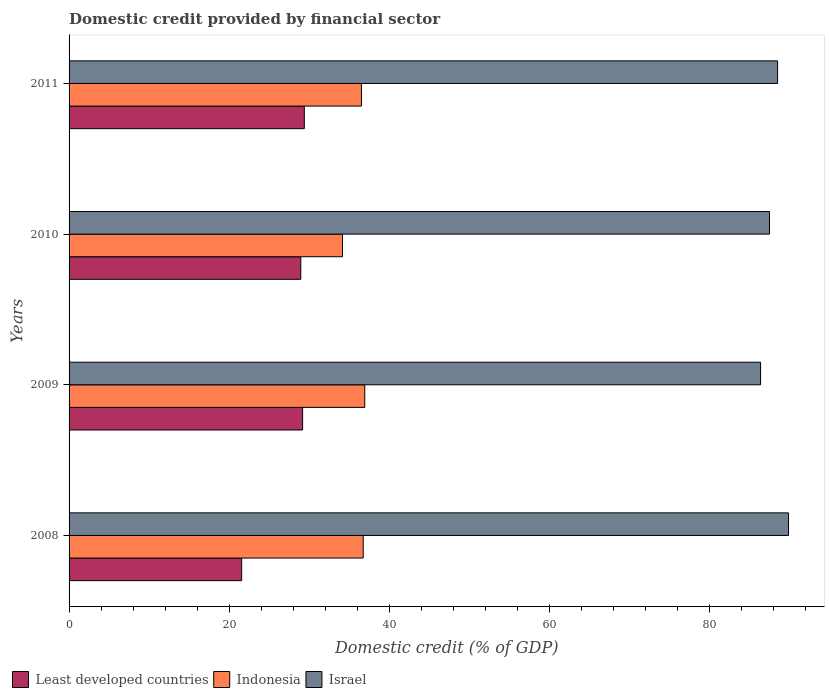How many groups of bars are there?
Give a very brief answer. 4. How many bars are there on the 4th tick from the top?
Your answer should be very brief. 3. How many bars are there on the 1st tick from the bottom?
Provide a succinct answer. 3. What is the label of the 1st group of bars from the top?
Give a very brief answer. 2011. What is the domestic credit in Least developed countries in 2009?
Offer a very short reply. 29.19. Across all years, what is the maximum domestic credit in Least developed countries?
Offer a terse response. 29.41. Across all years, what is the minimum domestic credit in Indonesia?
Provide a succinct answer. 34.18. What is the total domestic credit in Israel in the graph?
Your answer should be very brief. 352.52. What is the difference between the domestic credit in Israel in 2008 and that in 2009?
Make the answer very short. 3.49. What is the difference between the domestic credit in Least developed countries in 2010 and the domestic credit in Israel in 2008?
Your answer should be compact. -60.97. What is the average domestic credit in Indonesia per year?
Offer a very short reply. 36.12. In the year 2009, what is the difference between the domestic credit in Indonesia and domestic credit in Israel?
Your answer should be compact. -49.48. What is the ratio of the domestic credit in Israel in 2008 to that in 2011?
Your response must be concise. 1.02. Is the domestic credit in Indonesia in 2010 less than that in 2011?
Give a very brief answer. Yes. Is the difference between the domestic credit in Indonesia in 2008 and 2010 greater than the difference between the domestic credit in Israel in 2008 and 2010?
Offer a terse response. Yes. What is the difference between the highest and the second highest domestic credit in Indonesia?
Provide a short and direct response. 0.2. What is the difference between the highest and the lowest domestic credit in Indonesia?
Ensure brevity in your answer.  2.78. Is the sum of the domestic credit in Indonesia in 2009 and 2011 greater than the maximum domestic credit in Least developed countries across all years?
Your answer should be compact. Yes. What does the 3rd bar from the top in 2011 represents?
Make the answer very short. Least developed countries. What is the difference between two consecutive major ticks on the X-axis?
Your answer should be very brief. 20. Does the graph contain grids?
Offer a terse response. No. Where does the legend appear in the graph?
Your answer should be very brief. Bottom left. How are the legend labels stacked?
Your answer should be compact. Horizontal. What is the title of the graph?
Make the answer very short. Domestic credit provided by financial sector. Does "Zambia" appear as one of the legend labels in the graph?
Your answer should be compact. No. What is the label or title of the X-axis?
Your answer should be compact. Domestic credit (% of GDP). What is the Domestic credit (% of GDP) in Least developed countries in 2008?
Ensure brevity in your answer.  21.58. What is the Domestic credit (% of GDP) of Indonesia in 2008?
Ensure brevity in your answer.  36.77. What is the Domestic credit (% of GDP) in Israel in 2008?
Give a very brief answer. 89.94. What is the Domestic credit (% of GDP) of Least developed countries in 2009?
Your answer should be compact. 29.19. What is the Domestic credit (% of GDP) in Indonesia in 2009?
Your answer should be compact. 36.97. What is the Domestic credit (% of GDP) of Israel in 2009?
Your response must be concise. 86.45. What is the Domestic credit (% of GDP) in Least developed countries in 2010?
Your response must be concise. 28.97. What is the Domestic credit (% of GDP) in Indonesia in 2010?
Offer a terse response. 34.18. What is the Domestic credit (% of GDP) in Israel in 2010?
Your response must be concise. 87.56. What is the Domestic credit (% of GDP) in Least developed countries in 2011?
Offer a very short reply. 29.41. What is the Domestic credit (% of GDP) in Indonesia in 2011?
Your response must be concise. 36.55. What is the Domestic credit (% of GDP) of Israel in 2011?
Provide a short and direct response. 88.57. Across all years, what is the maximum Domestic credit (% of GDP) in Least developed countries?
Make the answer very short. 29.41. Across all years, what is the maximum Domestic credit (% of GDP) of Indonesia?
Offer a very short reply. 36.97. Across all years, what is the maximum Domestic credit (% of GDP) of Israel?
Your answer should be very brief. 89.94. Across all years, what is the minimum Domestic credit (% of GDP) in Least developed countries?
Your answer should be very brief. 21.58. Across all years, what is the minimum Domestic credit (% of GDP) in Indonesia?
Provide a short and direct response. 34.18. Across all years, what is the minimum Domestic credit (% of GDP) in Israel?
Offer a very short reply. 86.45. What is the total Domestic credit (% of GDP) of Least developed countries in the graph?
Keep it short and to the point. 109.15. What is the total Domestic credit (% of GDP) of Indonesia in the graph?
Provide a short and direct response. 144.47. What is the total Domestic credit (% of GDP) in Israel in the graph?
Your response must be concise. 352.52. What is the difference between the Domestic credit (% of GDP) in Least developed countries in 2008 and that in 2009?
Your answer should be very brief. -7.62. What is the difference between the Domestic credit (% of GDP) of Indonesia in 2008 and that in 2009?
Make the answer very short. -0.2. What is the difference between the Domestic credit (% of GDP) in Israel in 2008 and that in 2009?
Offer a very short reply. 3.49. What is the difference between the Domestic credit (% of GDP) in Least developed countries in 2008 and that in 2010?
Your response must be concise. -7.39. What is the difference between the Domestic credit (% of GDP) in Indonesia in 2008 and that in 2010?
Keep it short and to the point. 2.59. What is the difference between the Domestic credit (% of GDP) of Israel in 2008 and that in 2010?
Provide a short and direct response. 2.38. What is the difference between the Domestic credit (% of GDP) of Least developed countries in 2008 and that in 2011?
Your answer should be compact. -7.83. What is the difference between the Domestic credit (% of GDP) in Indonesia in 2008 and that in 2011?
Make the answer very short. 0.22. What is the difference between the Domestic credit (% of GDP) in Israel in 2008 and that in 2011?
Ensure brevity in your answer.  1.37. What is the difference between the Domestic credit (% of GDP) in Least developed countries in 2009 and that in 2010?
Your response must be concise. 0.23. What is the difference between the Domestic credit (% of GDP) in Indonesia in 2009 and that in 2010?
Your response must be concise. 2.78. What is the difference between the Domestic credit (% of GDP) in Israel in 2009 and that in 2010?
Offer a terse response. -1.12. What is the difference between the Domestic credit (% of GDP) in Least developed countries in 2009 and that in 2011?
Your answer should be compact. -0.21. What is the difference between the Domestic credit (% of GDP) of Indonesia in 2009 and that in 2011?
Provide a short and direct response. 0.42. What is the difference between the Domestic credit (% of GDP) of Israel in 2009 and that in 2011?
Your response must be concise. -2.12. What is the difference between the Domestic credit (% of GDP) in Least developed countries in 2010 and that in 2011?
Make the answer very short. -0.44. What is the difference between the Domestic credit (% of GDP) in Indonesia in 2010 and that in 2011?
Give a very brief answer. -2.37. What is the difference between the Domestic credit (% of GDP) in Israel in 2010 and that in 2011?
Your response must be concise. -1.01. What is the difference between the Domestic credit (% of GDP) of Least developed countries in 2008 and the Domestic credit (% of GDP) of Indonesia in 2009?
Ensure brevity in your answer.  -15.39. What is the difference between the Domestic credit (% of GDP) in Least developed countries in 2008 and the Domestic credit (% of GDP) in Israel in 2009?
Your answer should be very brief. -64.87. What is the difference between the Domestic credit (% of GDP) of Indonesia in 2008 and the Domestic credit (% of GDP) of Israel in 2009?
Provide a short and direct response. -49.68. What is the difference between the Domestic credit (% of GDP) in Least developed countries in 2008 and the Domestic credit (% of GDP) in Indonesia in 2010?
Give a very brief answer. -12.61. What is the difference between the Domestic credit (% of GDP) of Least developed countries in 2008 and the Domestic credit (% of GDP) of Israel in 2010?
Provide a succinct answer. -65.99. What is the difference between the Domestic credit (% of GDP) in Indonesia in 2008 and the Domestic credit (% of GDP) in Israel in 2010?
Make the answer very short. -50.79. What is the difference between the Domestic credit (% of GDP) of Least developed countries in 2008 and the Domestic credit (% of GDP) of Indonesia in 2011?
Keep it short and to the point. -14.97. What is the difference between the Domestic credit (% of GDP) in Least developed countries in 2008 and the Domestic credit (% of GDP) in Israel in 2011?
Offer a terse response. -67. What is the difference between the Domestic credit (% of GDP) in Indonesia in 2008 and the Domestic credit (% of GDP) in Israel in 2011?
Ensure brevity in your answer.  -51.8. What is the difference between the Domestic credit (% of GDP) of Least developed countries in 2009 and the Domestic credit (% of GDP) of Indonesia in 2010?
Your answer should be compact. -4.99. What is the difference between the Domestic credit (% of GDP) in Least developed countries in 2009 and the Domestic credit (% of GDP) in Israel in 2010?
Keep it short and to the point. -58.37. What is the difference between the Domestic credit (% of GDP) of Indonesia in 2009 and the Domestic credit (% of GDP) of Israel in 2010?
Make the answer very short. -50.6. What is the difference between the Domestic credit (% of GDP) in Least developed countries in 2009 and the Domestic credit (% of GDP) in Indonesia in 2011?
Provide a succinct answer. -7.36. What is the difference between the Domestic credit (% of GDP) of Least developed countries in 2009 and the Domestic credit (% of GDP) of Israel in 2011?
Ensure brevity in your answer.  -59.38. What is the difference between the Domestic credit (% of GDP) of Indonesia in 2009 and the Domestic credit (% of GDP) of Israel in 2011?
Offer a terse response. -51.61. What is the difference between the Domestic credit (% of GDP) of Least developed countries in 2010 and the Domestic credit (% of GDP) of Indonesia in 2011?
Provide a succinct answer. -7.58. What is the difference between the Domestic credit (% of GDP) of Least developed countries in 2010 and the Domestic credit (% of GDP) of Israel in 2011?
Your answer should be compact. -59.61. What is the difference between the Domestic credit (% of GDP) of Indonesia in 2010 and the Domestic credit (% of GDP) of Israel in 2011?
Provide a succinct answer. -54.39. What is the average Domestic credit (% of GDP) of Least developed countries per year?
Keep it short and to the point. 27.29. What is the average Domestic credit (% of GDP) of Indonesia per year?
Keep it short and to the point. 36.12. What is the average Domestic credit (% of GDP) of Israel per year?
Provide a short and direct response. 88.13. In the year 2008, what is the difference between the Domestic credit (% of GDP) in Least developed countries and Domestic credit (% of GDP) in Indonesia?
Make the answer very short. -15.19. In the year 2008, what is the difference between the Domestic credit (% of GDP) in Least developed countries and Domestic credit (% of GDP) in Israel?
Your answer should be very brief. -68.36. In the year 2008, what is the difference between the Domestic credit (% of GDP) in Indonesia and Domestic credit (% of GDP) in Israel?
Provide a short and direct response. -53.17. In the year 2009, what is the difference between the Domestic credit (% of GDP) in Least developed countries and Domestic credit (% of GDP) in Indonesia?
Your answer should be compact. -7.77. In the year 2009, what is the difference between the Domestic credit (% of GDP) of Least developed countries and Domestic credit (% of GDP) of Israel?
Keep it short and to the point. -57.25. In the year 2009, what is the difference between the Domestic credit (% of GDP) in Indonesia and Domestic credit (% of GDP) in Israel?
Your response must be concise. -49.48. In the year 2010, what is the difference between the Domestic credit (% of GDP) of Least developed countries and Domestic credit (% of GDP) of Indonesia?
Keep it short and to the point. -5.22. In the year 2010, what is the difference between the Domestic credit (% of GDP) of Least developed countries and Domestic credit (% of GDP) of Israel?
Offer a very short reply. -58.6. In the year 2010, what is the difference between the Domestic credit (% of GDP) in Indonesia and Domestic credit (% of GDP) in Israel?
Give a very brief answer. -53.38. In the year 2011, what is the difference between the Domestic credit (% of GDP) of Least developed countries and Domestic credit (% of GDP) of Indonesia?
Your response must be concise. -7.14. In the year 2011, what is the difference between the Domestic credit (% of GDP) of Least developed countries and Domestic credit (% of GDP) of Israel?
Offer a terse response. -59.17. In the year 2011, what is the difference between the Domestic credit (% of GDP) of Indonesia and Domestic credit (% of GDP) of Israel?
Your answer should be compact. -52.02. What is the ratio of the Domestic credit (% of GDP) in Least developed countries in 2008 to that in 2009?
Your answer should be compact. 0.74. What is the ratio of the Domestic credit (% of GDP) of Israel in 2008 to that in 2009?
Offer a terse response. 1.04. What is the ratio of the Domestic credit (% of GDP) of Least developed countries in 2008 to that in 2010?
Offer a very short reply. 0.74. What is the ratio of the Domestic credit (% of GDP) in Indonesia in 2008 to that in 2010?
Make the answer very short. 1.08. What is the ratio of the Domestic credit (% of GDP) of Israel in 2008 to that in 2010?
Give a very brief answer. 1.03. What is the ratio of the Domestic credit (% of GDP) of Least developed countries in 2008 to that in 2011?
Give a very brief answer. 0.73. What is the ratio of the Domestic credit (% of GDP) of Israel in 2008 to that in 2011?
Your response must be concise. 1.02. What is the ratio of the Domestic credit (% of GDP) in Least developed countries in 2009 to that in 2010?
Provide a succinct answer. 1.01. What is the ratio of the Domestic credit (% of GDP) of Indonesia in 2009 to that in 2010?
Keep it short and to the point. 1.08. What is the ratio of the Domestic credit (% of GDP) in Israel in 2009 to that in 2010?
Your response must be concise. 0.99. What is the ratio of the Domestic credit (% of GDP) in Least developed countries in 2009 to that in 2011?
Ensure brevity in your answer.  0.99. What is the ratio of the Domestic credit (% of GDP) in Indonesia in 2009 to that in 2011?
Ensure brevity in your answer.  1.01. What is the ratio of the Domestic credit (% of GDP) in Israel in 2009 to that in 2011?
Ensure brevity in your answer.  0.98. What is the ratio of the Domestic credit (% of GDP) of Least developed countries in 2010 to that in 2011?
Offer a terse response. 0.98. What is the ratio of the Domestic credit (% of GDP) of Indonesia in 2010 to that in 2011?
Your response must be concise. 0.94. What is the difference between the highest and the second highest Domestic credit (% of GDP) in Least developed countries?
Provide a short and direct response. 0.21. What is the difference between the highest and the second highest Domestic credit (% of GDP) in Indonesia?
Provide a succinct answer. 0.2. What is the difference between the highest and the second highest Domestic credit (% of GDP) of Israel?
Make the answer very short. 1.37. What is the difference between the highest and the lowest Domestic credit (% of GDP) of Least developed countries?
Ensure brevity in your answer.  7.83. What is the difference between the highest and the lowest Domestic credit (% of GDP) in Indonesia?
Ensure brevity in your answer.  2.78. What is the difference between the highest and the lowest Domestic credit (% of GDP) of Israel?
Keep it short and to the point. 3.49. 